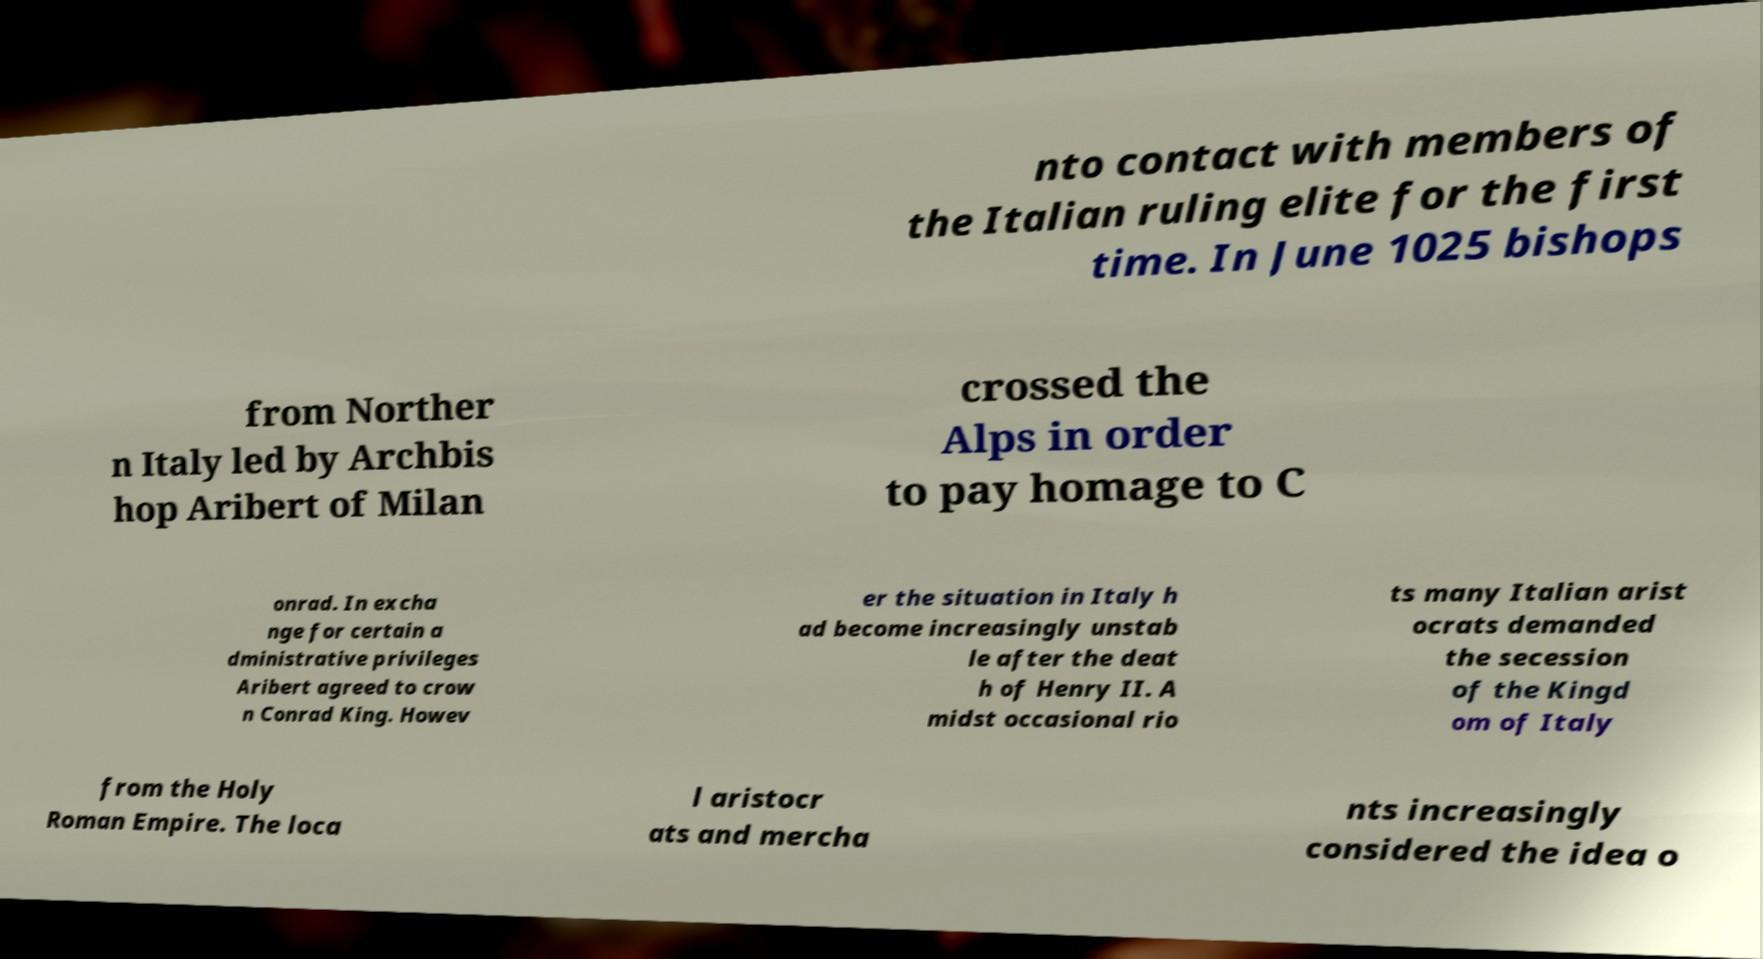Please identify and transcribe the text found in this image. nto contact with members of the Italian ruling elite for the first time. In June 1025 bishops from Norther n Italy led by Archbis hop Aribert of Milan crossed the Alps in order to pay homage to C onrad. In excha nge for certain a dministrative privileges Aribert agreed to crow n Conrad King. Howev er the situation in Italy h ad become increasingly unstab le after the deat h of Henry II. A midst occasional rio ts many Italian arist ocrats demanded the secession of the Kingd om of Italy from the Holy Roman Empire. The loca l aristocr ats and mercha nts increasingly considered the idea o 